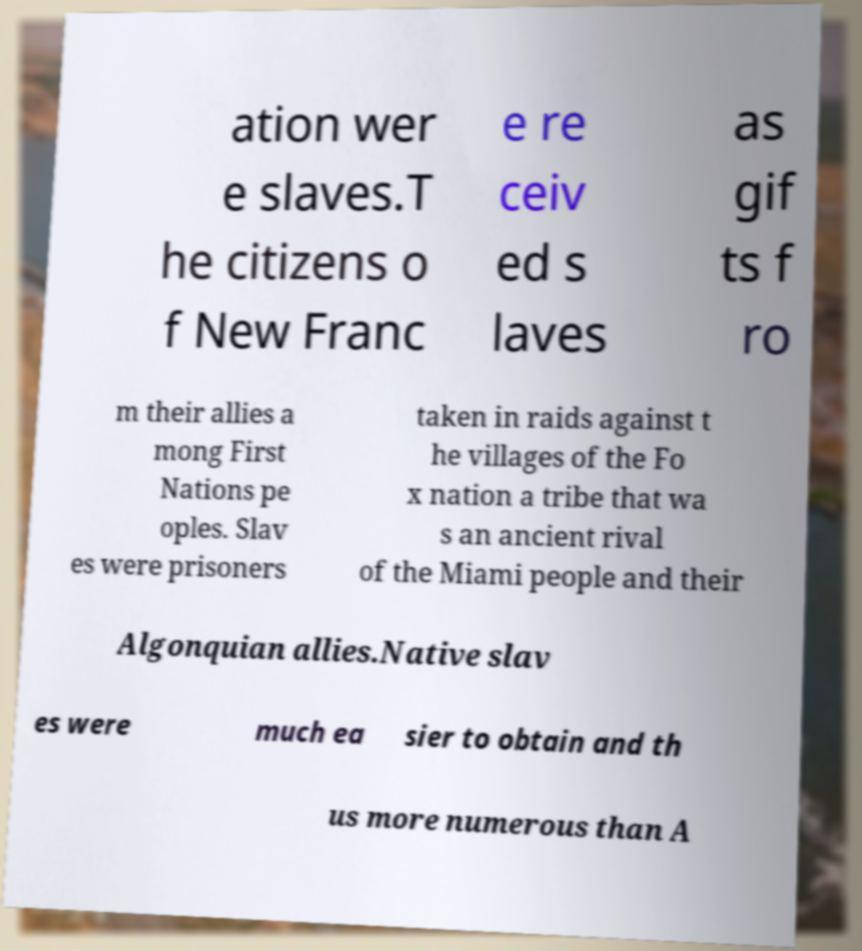Can you accurately transcribe the text from the provided image for me? ation wer e slaves.T he citizens o f New Franc e re ceiv ed s laves as gif ts f ro m their allies a mong First Nations pe oples. Slav es were prisoners taken in raids against t he villages of the Fo x nation a tribe that wa s an ancient rival of the Miami people and their Algonquian allies.Native slav es were much ea sier to obtain and th us more numerous than A 